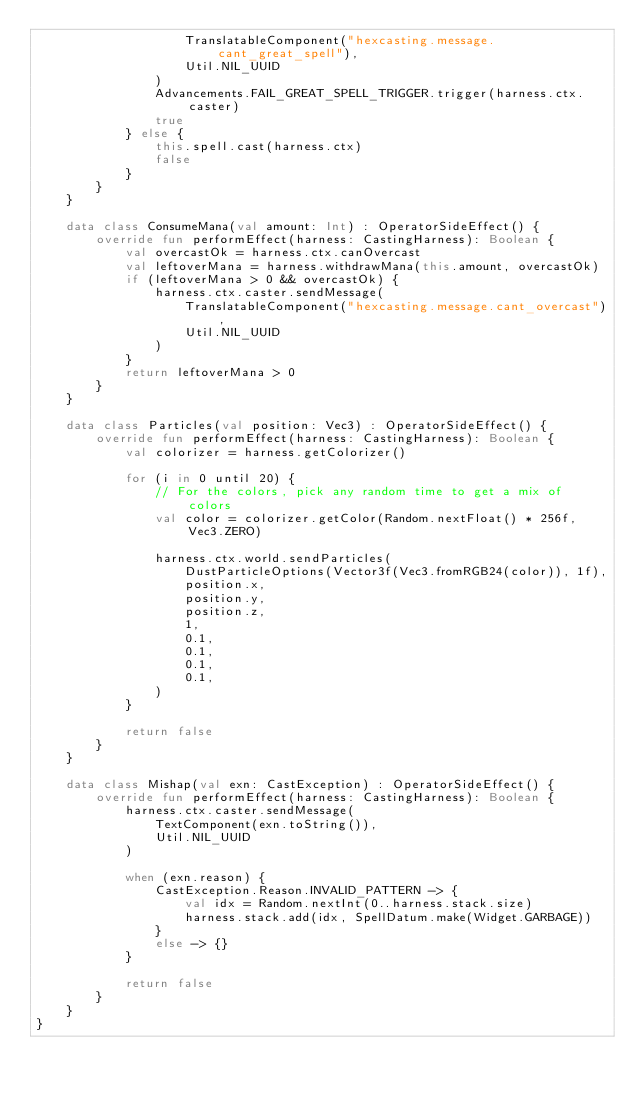Convert code to text. <code><loc_0><loc_0><loc_500><loc_500><_Kotlin_>                    TranslatableComponent("hexcasting.message.cant_great_spell"),
                    Util.NIL_UUID
                )
                Advancements.FAIL_GREAT_SPELL_TRIGGER.trigger(harness.ctx.caster)
                true
            } else {
                this.spell.cast(harness.ctx)
                false
            }
        }
    }

    data class ConsumeMana(val amount: Int) : OperatorSideEffect() {
        override fun performEffect(harness: CastingHarness): Boolean {
            val overcastOk = harness.ctx.canOvercast
            val leftoverMana = harness.withdrawMana(this.amount, overcastOk)
            if (leftoverMana > 0 && overcastOk) {
                harness.ctx.caster.sendMessage(
                    TranslatableComponent("hexcasting.message.cant_overcast"),
                    Util.NIL_UUID
                )
            }
            return leftoverMana > 0
        }
    }

    data class Particles(val position: Vec3) : OperatorSideEffect() {
        override fun performEffect(harness: CastingHarness): Boolean {
            val colorizer = harness.getColorizer()

            for (i in 0 until 20) {
                // For the colors, pick any random time to get a mix of colors
                val color = colorizer.getColor(Random.nextFloat() * 256f, Vec3.ZERO)

                harness.ctx.world.sendParticles(
                    DustParticleOptions(Vector3f(Vec3.fromRGB24(color)), 1f),
                    position.x,
                    position.y,
                    position.z,
                    1,
                    0.1,
                    0.1,
                    0.1,
                    0.1,
                )
            }

            return false
        }
    }

    data class Mishap(val exn: CastException) : OperatorSideEffect() {
        override fun performEffect(harness: CastingHarness): Boolean {
            harness.ctx.caster.sendMessage(
                TextComponent(exn.toString()),
                Util.NIL_UUID
            )

            when (exn.reason) {
                CastException.Reason.INVALID_PATTERN -> {
                    val idx = Random.nextInt(0..harness.stack.size)
                    harness.stack.add(idx, SpellDatum.make(Widget.GARBAGE))
                }
                else -> {}
            }

            return false
        }
    }
}</code> 